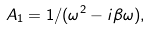<formula> <loc_0><loc_0><loc_500><loc_500>A _ { 1 } = 1 / ( \omega ^ { 2 } - i \beta \omega ) ,</formula> 